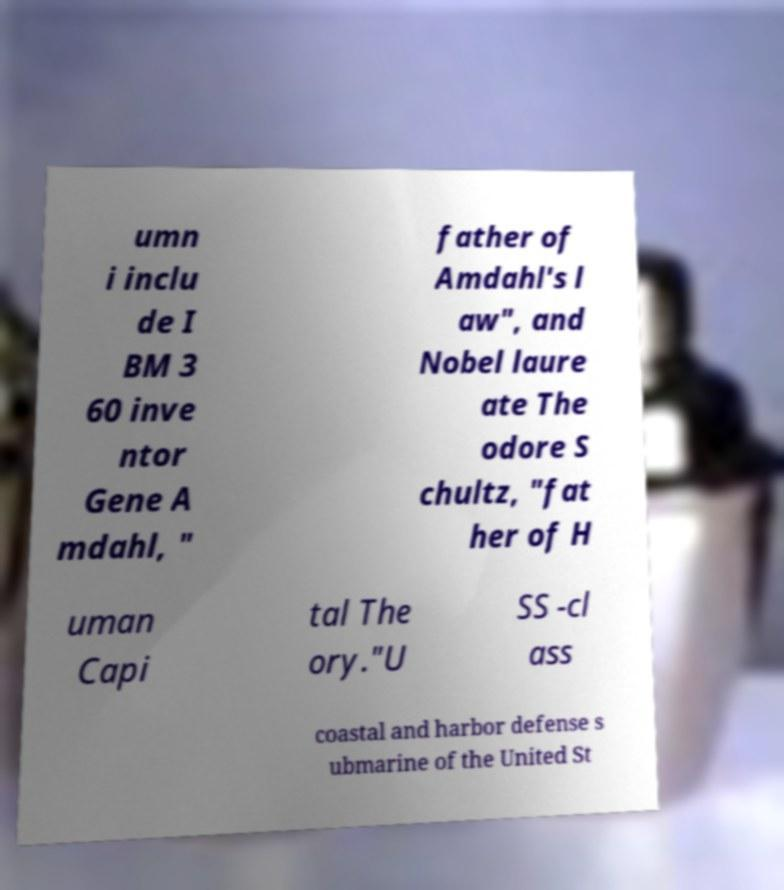Please read and relay the text visible in this image. What does it say? umn i inclu de I BM 3 60 inve ntor Gene A mdahl, " father of Amdahl's l aw", and Nobel laure ate The odore S chultz, "fat her of H uman Capi tal The ory."U SS -cl ass coastal and harbor defense s ubmarine of the United St 